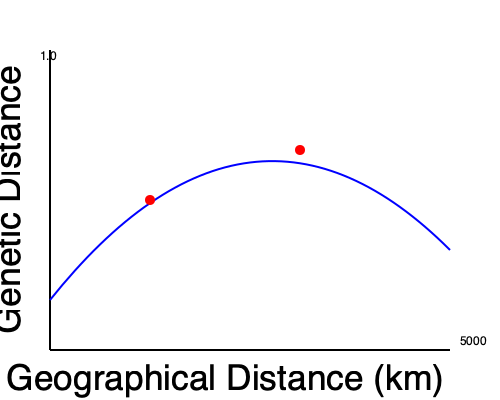Analyze the graph showing the relationship between genetic distance and geographical distance for populations of a species. What phenomenon does the non-linear curve suggest, and how would you explain the positions of the two red dots relative to the curve? 1. Graph interpretation:
   - X-axis represents geographical distance (up to 5000 km)
   - Y-axis represents genetic distance (up to 1.0)
   - Blue curve shows the relationship between genetic and geographical distance

2. Non-linear relationship:
   - The curve is not a straight line, indicating a non-linear relationship
   - It shows a rapid increase in genetic distance at shorter geographical distances
   - The rate of increase slows down at larger geographical distances

3. This pattern suggests isolation by distance (IBD):
   - Gene flow decreases with increasing geographical distance
   - Genetic drift has a stronger effect on geographically distant populations

4. Mathematical representation:
   The relationship can be modeled using the equation:
   $$ F_{ST} \approx \frac{1}{1 + 4\pi D\sigma^2} $$
   Where $F_{ST}$ is genetic distance, $D$ is population density, and $\sigma^2$ is the variance in parent-offspring distance

5. Red dots analysis:
   - Lower dot: Closer to the curve, represents a typical population following the IBD pattern
   - Upper dot: Above the curve, indicates higher genetic distance than expected for its geographical distance

6. Possible explanations for the upper dot:
   - Presence of a geographical barrier (e.g., mountain, river) reducing gene flow
   - Local adaptation leading to genetic divergence
   - Historical events (e.g., founder effect, bottleneck) affecting genetic diversity

7. Implications for evolutionary study:
   - Importance of considering both geographical and genetic distances in population genetics
   - Need to investigate outlier populations for unique evolutionary processes
Answer: Isolation by distance; upper dot suggests reduced gene flow or local adaptation 